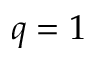<formula> <loc_0><loc_0><loc_500><loc_500>q = 1</formula> 